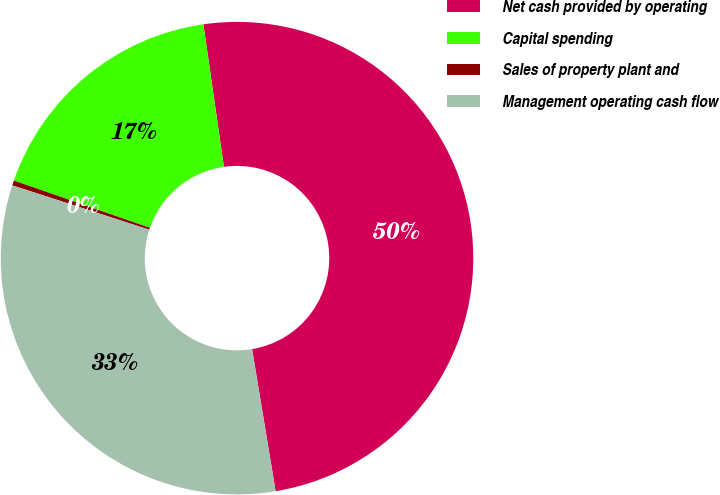<chart> <loc_0><loc_0><loc_500><loc_500><pie_chart><fcel>Net cash provided by operating<fcel>Capital spending<fcel>Sales of property plant and<fcel>Management operating cash flow<nl><fcel>49.66%<fcel>17.4%<fcel>0.34%<fcel>32.6%<nl></chart> 